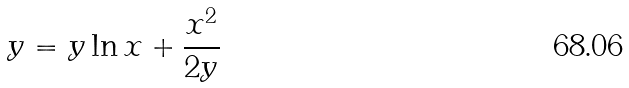Convert formula to latex. <formula><loc_0><loc_0><loc_500><loc_500>y = y \ln x + \frac { x ^ { 2 } } { 2 y }</formula> 